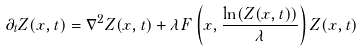<formula> <loc_0><loc_0><loc_500><loc_500>\partial _ { t } Z ( x , t ) = \nabla ^ { 2 } Z ( x , t ) + { \lambda } F \left ( x , \frac { \ln ( Z ( x , t ) ) } { \lambda } \right ) Z ( x , t )</formula> 